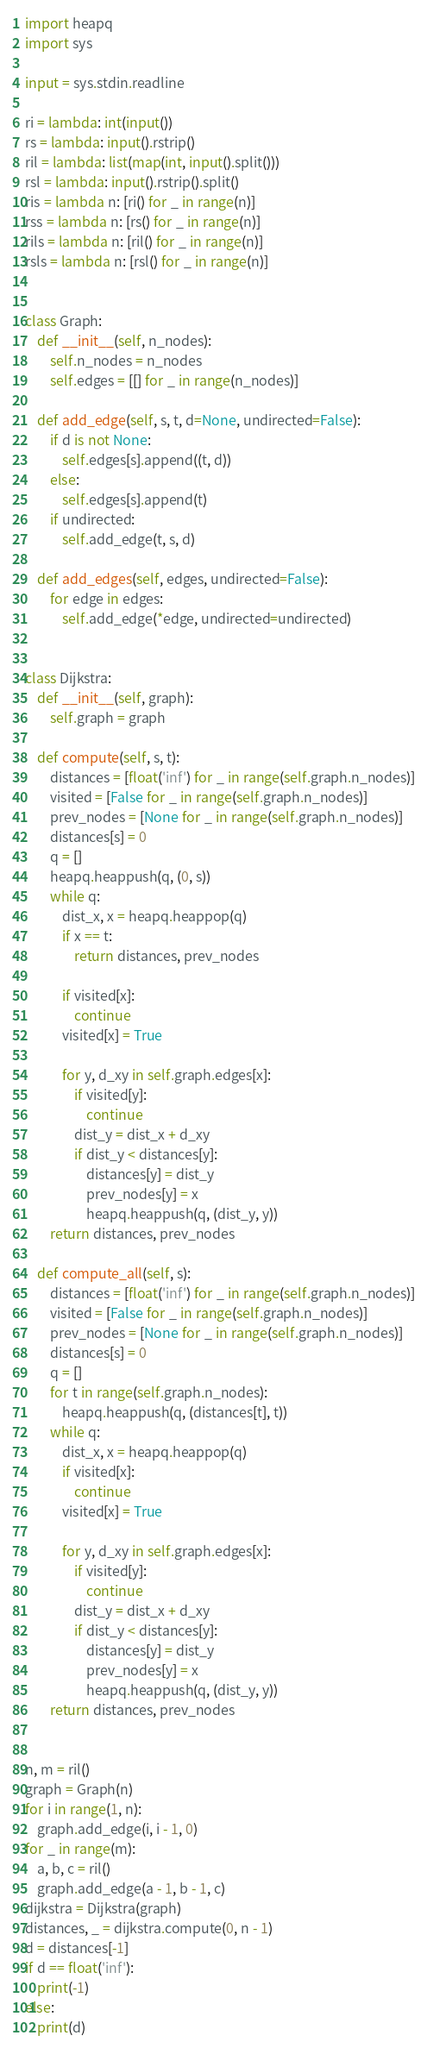Convert code to text. <code><loc_0><loc_0><loc_500><loc_500><_Python_>import heapq
import sys

input = sys.stdin.readline

ri = lambda: int(input())
rs = lambda: input().rstrip()
ril = lambda: list(map(int, input().split()))
rsl = lambda: input().rstrip().split()
ris = lambda n: [ri() for _ in range(n)]
rss = lambda n: [rs() for _ in range(n)]
rils = lambda n: [ril() for _ in range(n)]
rsls = lambda n: [rsl() for _ in range(n)]


class Graph:
    def __init__(self, n_nodes):
        self.n_nodes = n_nodes
        self.edges = [[] for _ in range(n_nodes)]

    def add_edge(self, s, t, d=None, undirected=False):
        if d is not None:
            self.edges[s].append((t, d))
        else:
            self.edges[s].append(t)
        if undirected:
            self.add_edge(t, s, d)

    def add_edges(self, edges, undirected=False):
        for edge in edges:
            self.add_edge(*edge, undirected=undirected)


class Dijkstra:
    def __init__(self, graph):
        self.graph = graph

    def compute(self, s, t):
        distances = [float('inf') for _ in range(self.graph.n_nodes)]
        visited = [False for _ in range(self.graph.n_nodes)]
        prev_nodes = [None for _ in range(self.graph.n_nodes)]
        distances[s] = 0
        q = []
        heapq.heappush(q, (0, s))
        while q:
            dist_x, x = heapq.heappop(q)
            if x == t:
                return distances, prev_nodes

            if visited[x]:
                continue
            visited[x] = True

            for y, d_xy in self.graph.edges[x]:
                if visited[y]:
                    continue
                dist_y = dist_x + d_xy
                if dist_y < distances[y]:
                    distances[y] = dist_y
                    prev_nodes[y] = x
                    heapq.heappush(q, (dist_y, y))
        return distances, prev_nodes

    def compute_all(self, s):
        distances = [float('inf') for _ in range(self.graph.n_nodes)]
        visited = [False for _ in range(self.graph.n_nodes)]
        prev_nodes = [None for _ in range(self.graph.n_nodes)]
        distances[s] = 0
        q = []
        for t in range(self.graph.n_nodes):
            heapq.heappush(q, (distances[t], t))
        while q:
            dist_x, x = heapq.heappop(q)
            if visited[x]:
                continue
            visited[x] = True

            for y, d_xy in self.graph.edges[x]:
                if visited[y]:
                    continue
                dist_y = dist_x + d_xy
                if dist_y < distances[y]:
                    distances[y] = dist_y
                    prev_nodes[y] = x
                    heapq.heappush(q, (dist_y, y))
        return distances, prev_nodes


n, m = ril()
graph = Graph(n)
for i in range(1, n):
    graph.add_edge(i, i - 1, 0)
for _ in range(m):
    a, b, c = ril()
    graph.add_edge(a - 1, b - 1, c)
dijkstra = Dijkstra(graph)
distances, _ = dijkstra.compute(0, n - 1)
d = distances[-1]
if d == float('inf'):
    print(-1)
else:
    print(d)</code> 